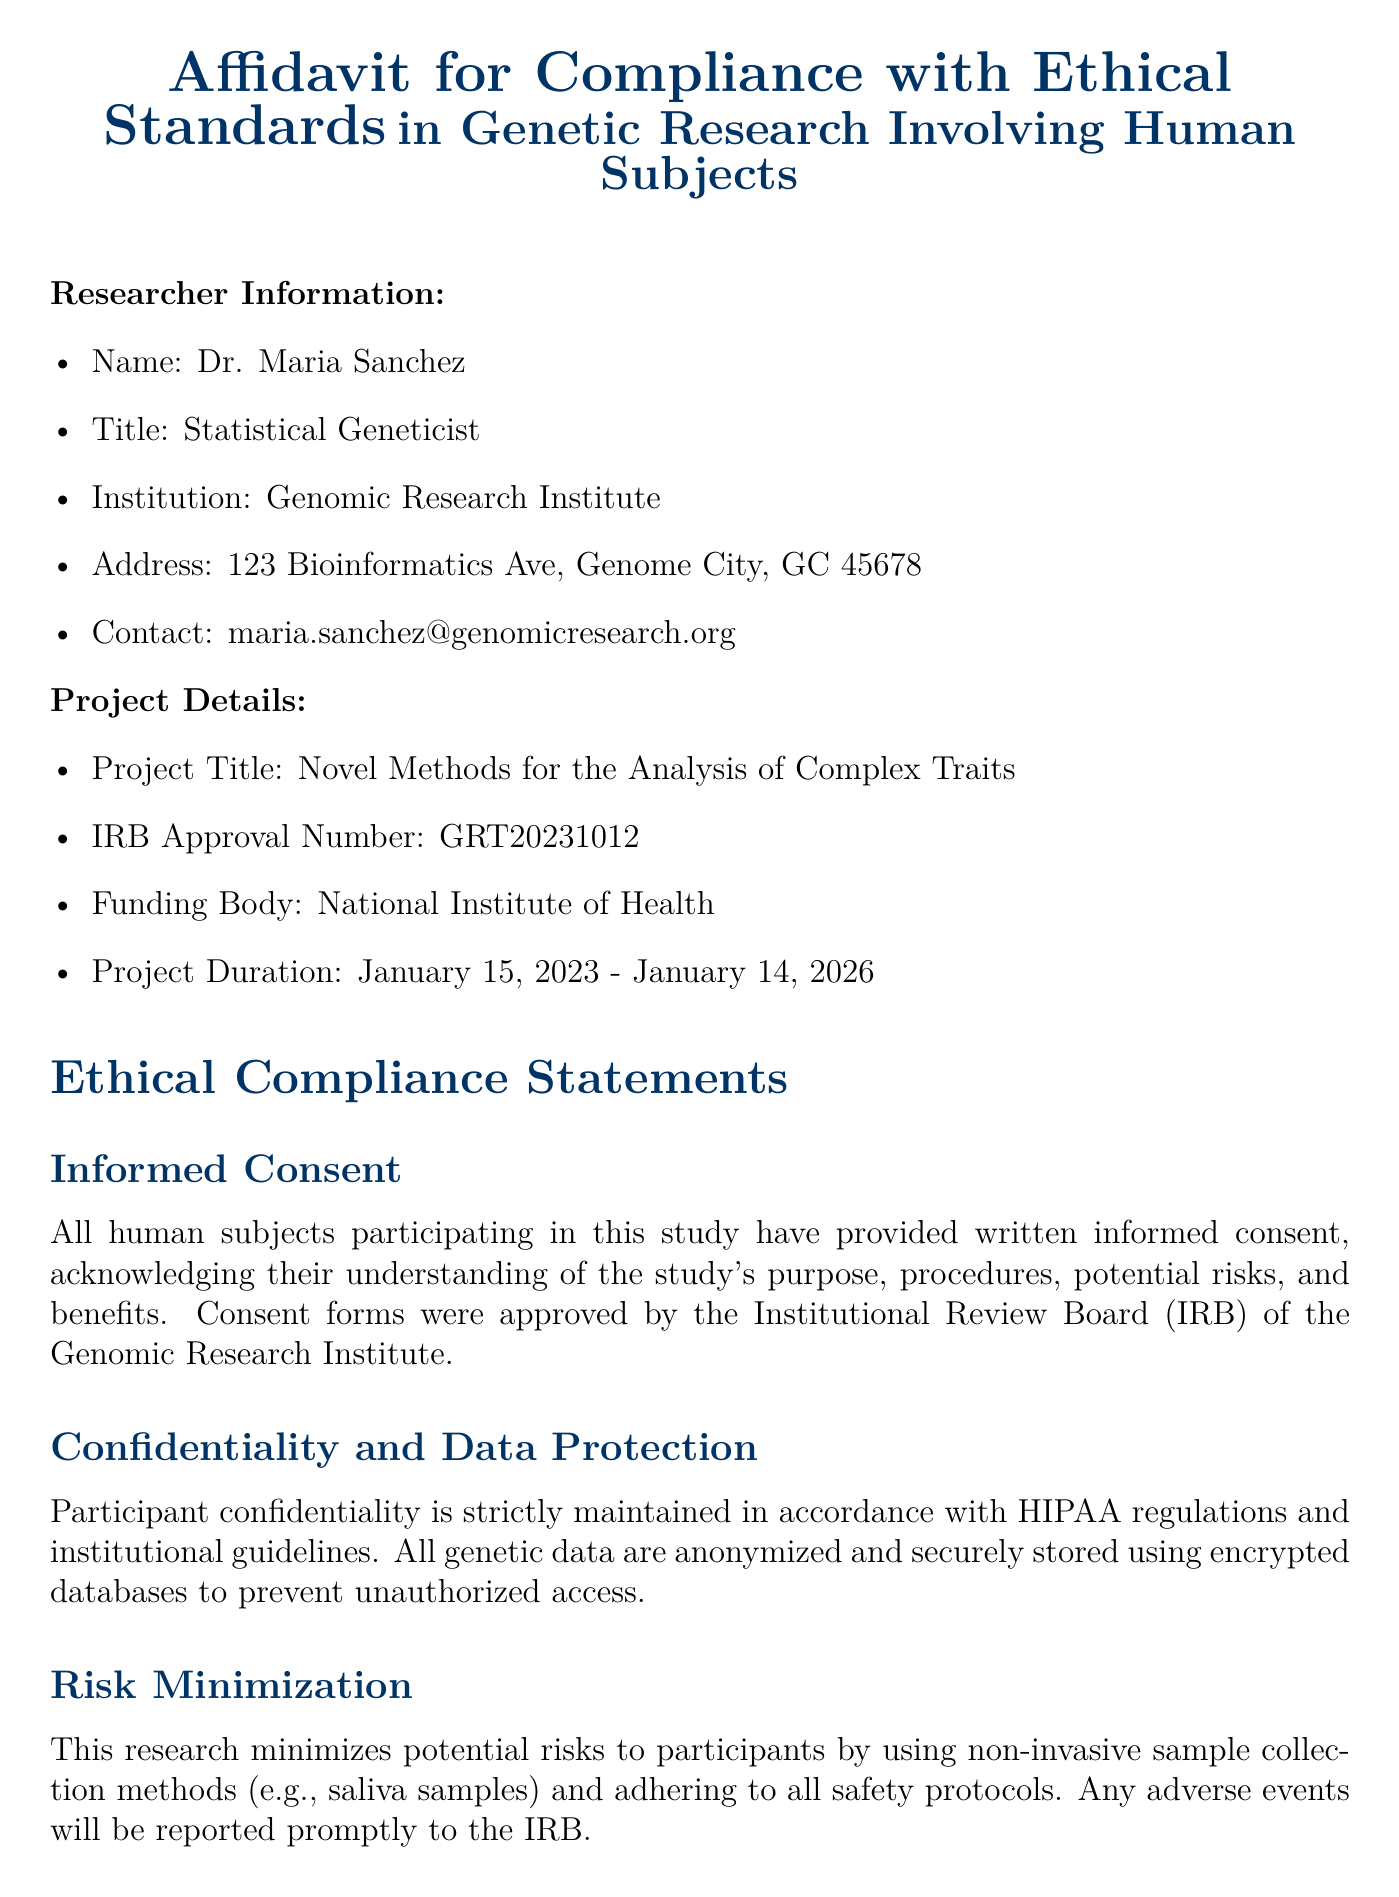what is the researcher's name? The researcher's name is listed at the beginning of the document under Researcher Information.
Answer: Dr. Maria Sanchez what is the project title? The project title is mentioned in the Project Details section of the document.
Answer: Novel Methods for the Analysis of Complex Traits what is the IRB Approval Number? The IRB Approval Number can be found in the Project Details section.
Answer: GRT20231012 what is the project duration? The project duration is specified in the Project Details section of the document.
Answer: January 15, 2023 - January 14, 2026 how are participant confidentiality and data protection ensured? This is discussed in the Ethical Compliance Statements under the Confidentiality and Data Protection subsection.
Answer: HIPAA regulations and institutional guidelines what measures are taken to minimize risk to participants? This is outlined in the Ethical Compliance Statements under the Risk Minimization subsection.
Answer: Non-invasive sample collection methods what type of oversight does the study have? The type of oversight for the study is addressed in the Ongoing Ethical Oversight subsection.
Answer: Continuous ethical oversight by the IRB what is the purpose of the Certification statement? The Certification statement is a formal declaration of compliance with ethical standards.
Answer: Affirm compliance with ethical standards who affirms compliance with ethical standards? The individual affirming compliance is identified at the end of the document.
Answer: Dr. Maria Sanchez 